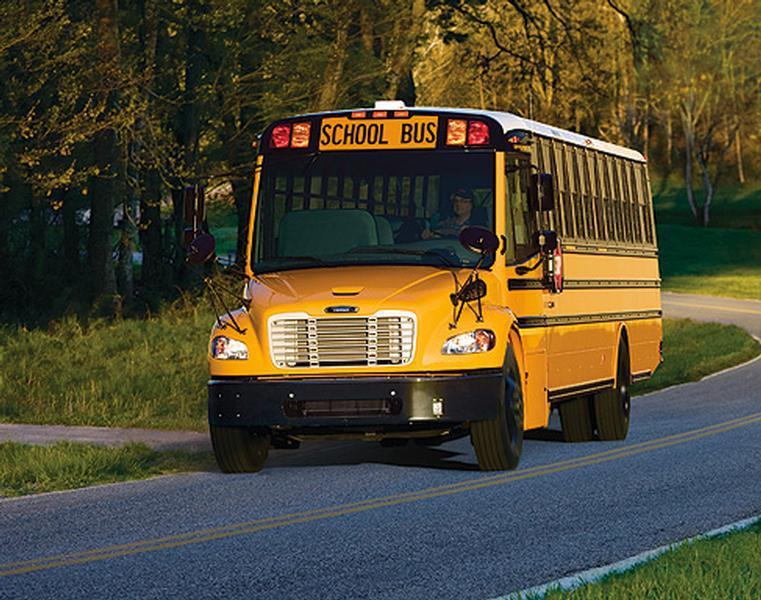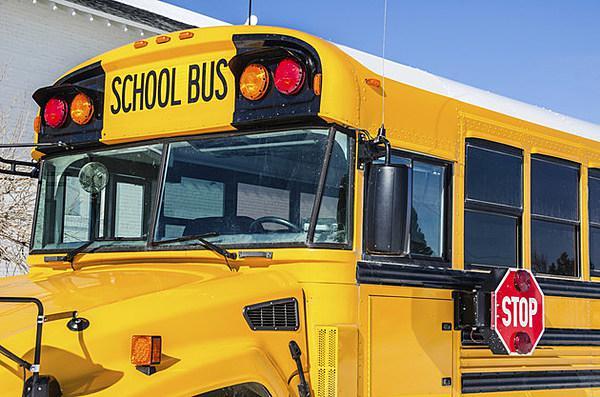The first image is the image on the left, the second image is the image on the right. Analyze the images presented: Is the assertion "In at least one image there is a single view of a flat front end bus with its windshield wiper up." valid? Answer yes or no. No. 